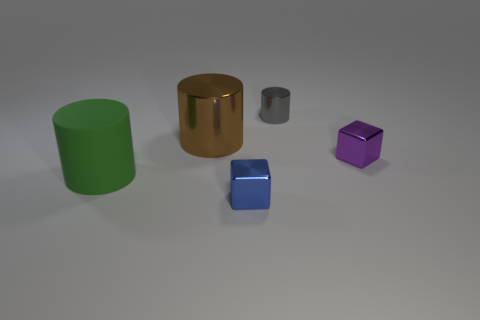What can you infer about the setting or environment where these objects are placed? The objects are placed on a flat, matte surface with a neutral gray tone, set within a softly lit environment that casts diffuse shadows. The absence of any distinct features or objects in the background suggests these items are showcased, perhaps for display or in a controlled studio setting for photographic purposes. 